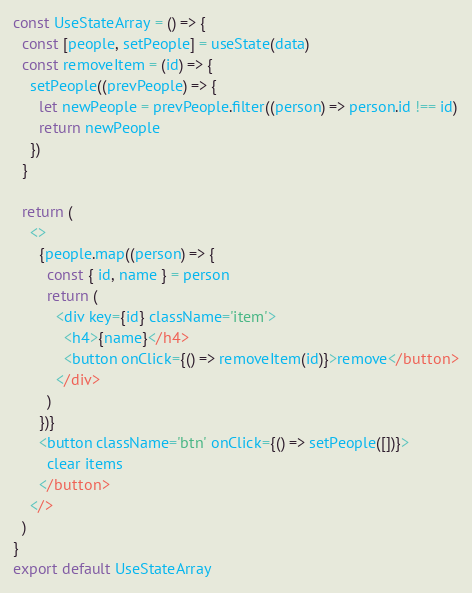<code> <loc_0><loc_0><loc_500><loc_500><_JavaScript_>const UseStateArray = () => {
  const [people, setPeople] = useState(data)
  const removeItem = (id) => {
    setPeople((prevPeople) => {
      let newPeople = prevPeople.filter((person) => person.id !== id)
      return newPeople
    })
  }

  return (
    <>
      {people.map((person) => {
        const { id, name } = person
        return (
          <div key={id} className='item'>
            <h4>{name}</h4>
            <button onClick={() => removeItem(id)}>remove</button>
          </div>
        )
      })}
      <button className='btn' onClick={() => setPeople([])}>
        clear items
      </button>
    </>
  )
}
export default UseStateArray
</code> 